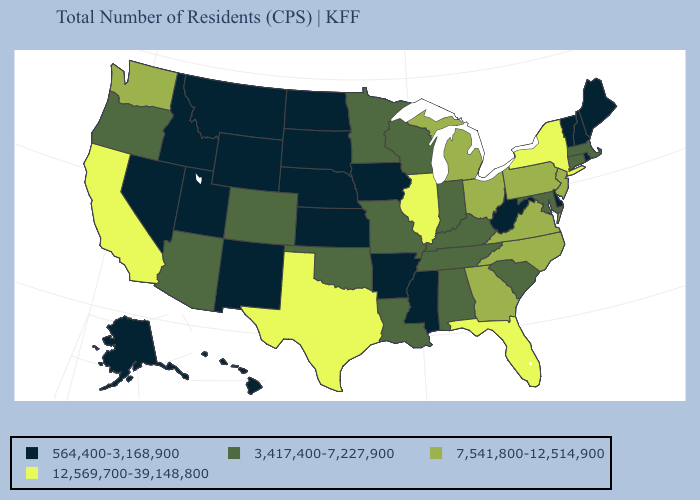Name the states that have a value in the range 564,400-3,168,900?
Short answer required. Alaska, Arkansas, Delaware, Hawaii, Idaho, Iowa, Kansas, Maine, Mississippi, Montana, Nebraska, Nevada, New Hampshire, New Mexico, North Dakota, Rhode Island, South Dakota, Utah, Vermont, West Virginia, Wyoming. Among the states that border Alabama , does Mississippi have the lowest value?
Give a very brief answer. Yes. Name the states that have a value in the range 3,417,400-7,227,900?
Concise answer only. Alabama, Arizona, Colorado, Connecticut, Indiana, Kentucky, Louisiana, Maryland, Massachusetts, Minnesota, Missouri, Oklahoma, Oregon, South Carolina, Tennessee, Wisconsin. What is the value of New Mexico?
Be succinct. 564,400-3,168,900. Does Florida have the highest value in the South?
Keep it brief. Yes. Which states have the lowest value in the South?
Be succinct. Arkansas, Delaware, Mississippi, West Virginia. What is the highest value in the USA?
Be succinct. 12,569,700-39,148,800. How many symbols are there in the legend?
Short answer required. 4. Does Idaho have the highest value in the West?
Short answer required. No. Does Oklahoma have the same value as Arizona?
Concise answer only. Yes. Name the states that have a value in the range 564,400-3,168,900?
Quick response, please. Alaska, Arkansas, Delaware, Hawaii, Idaho, Iowa, Kansas, Maine, Mississippi, Montana, Nebraska, Nevada, New Hampshire, New Mexico, North Dakota, Rhode Island, South Dakota, Utah, Vermont, West Virginia, Wyoming. Does Illinois have the highest value in the USA?
Be succinct. Yes. Name the states that have a value in the range 12,569,700-39,148,800?
Give a very brief answer. California, Florida, Illinois, New York, Texas. What is the value of California?
Give a very brief answer. 12,569,700-39,148,800. Name the states that have a value in the range 7,541,800-12,514,900?
Be succinct. Georgia, Michigan, New Jersey, North Carolina, Ohio, Pennsylvania, Virginia, Washington. 